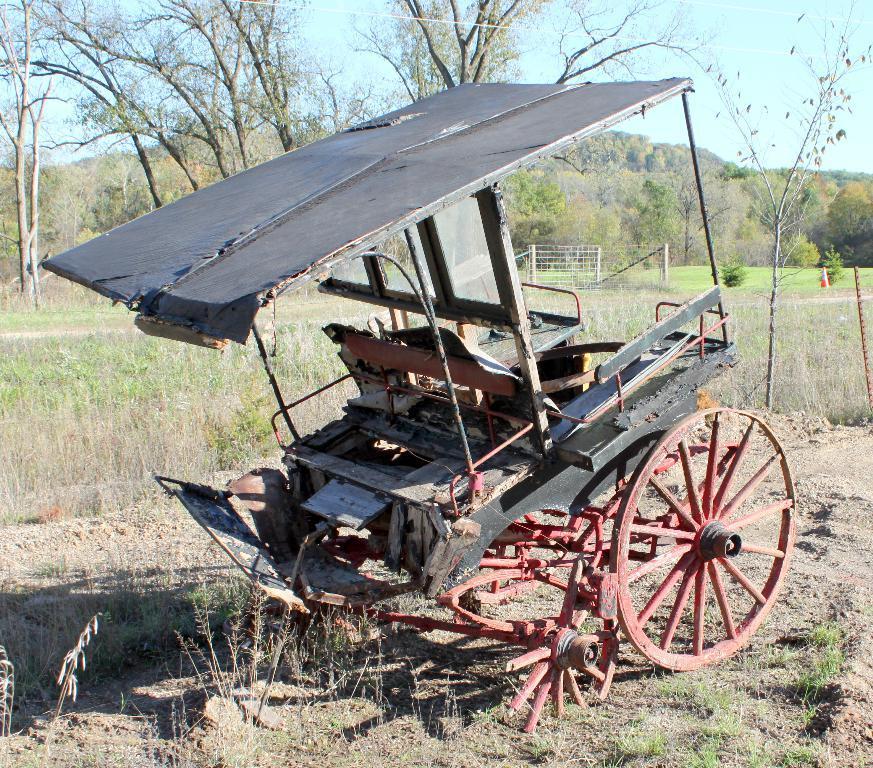Please provide a concise description of this image. In this image I can see a cart on grass. In the background I can see plants, fence, trees, mountains and the sky. This image is taken may be in a farm. 